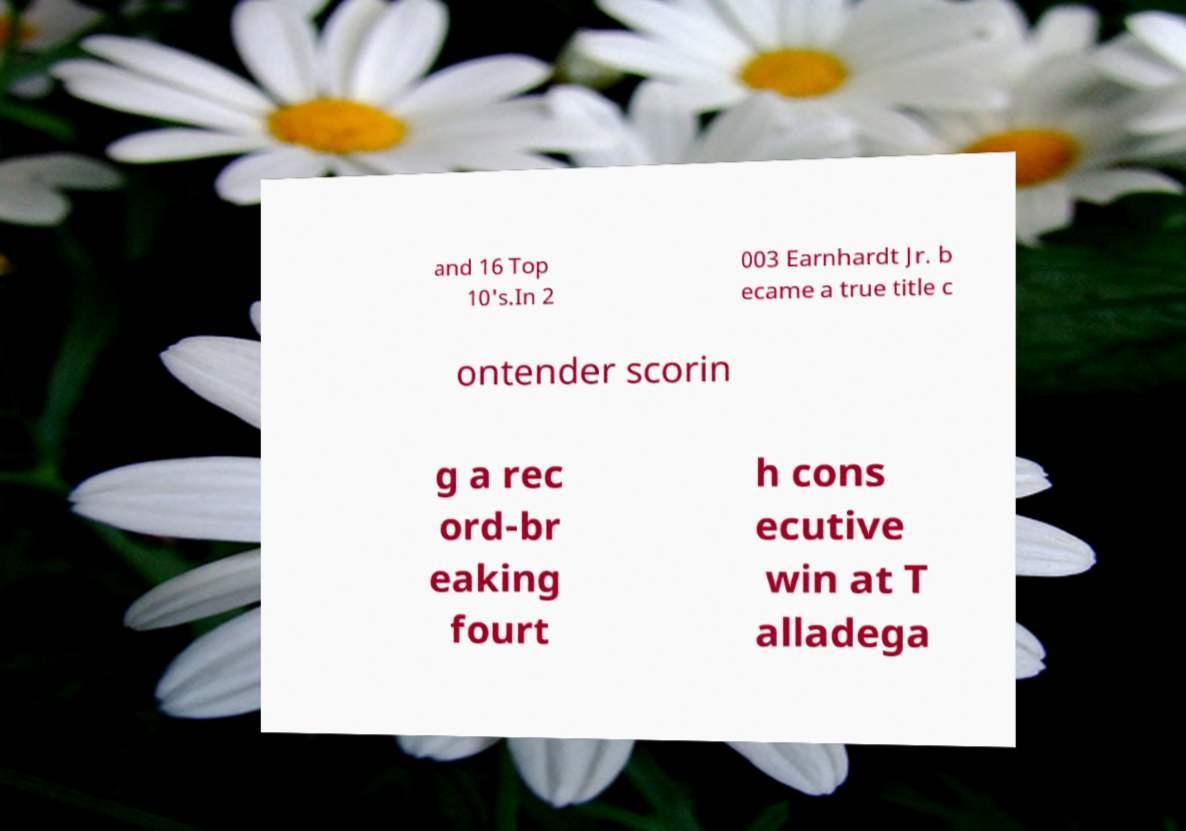What messages or text are displayed in this image? I need them in a readable, typed format. and 16 Top 10's.In 2 003 Earnhardt Jr. b ecame a true title c ontender scorin g a rec ord-br eaking fourt h cons ecutive win at T alladega 